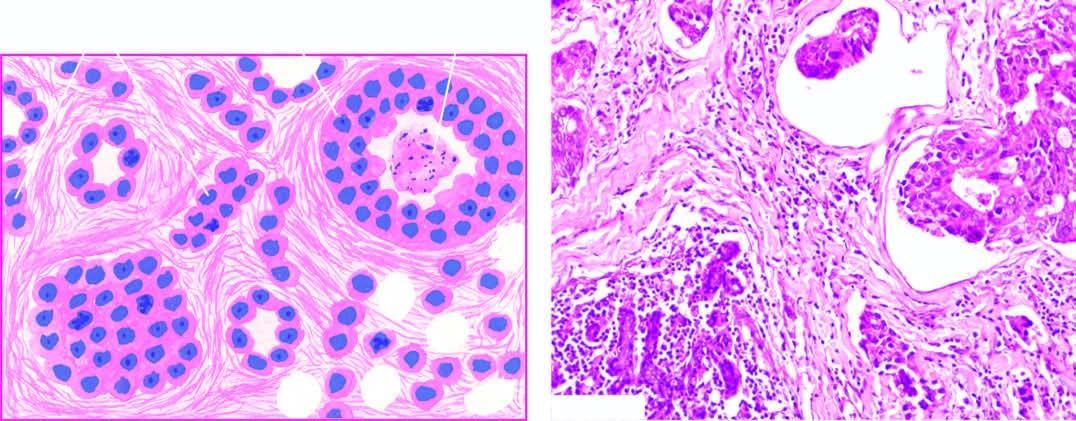what include formation of solid nests, cords, gland-like structures and intraductal growth pattern of anaplastic tumour cells?
Answer the question using a single word or phrase. Microscopic features 